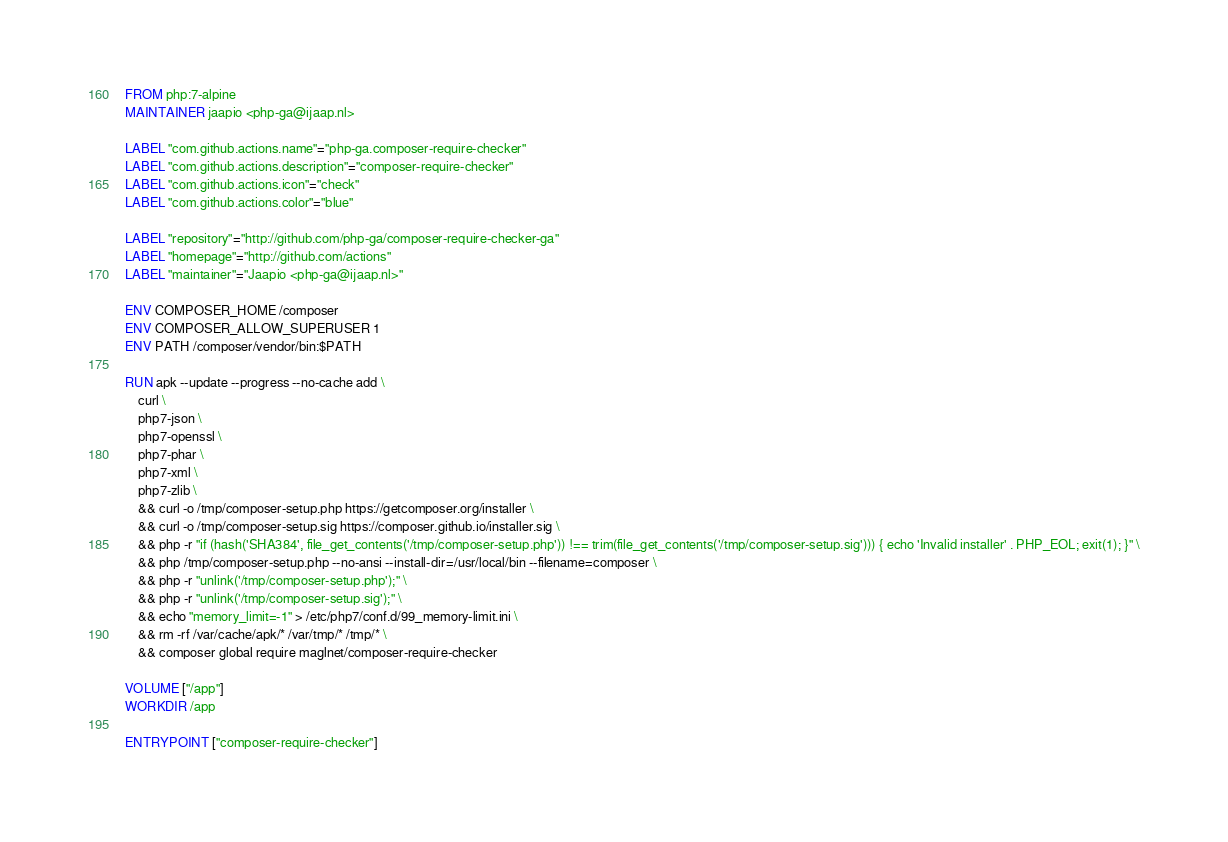<code> <loc_0><loc_0><loc_500><loc_500><_Dockerfile_>FROM php:7-alpine
MAINTAINER jaapio <php-ga@ijaap.nl>

LABEL "com.github.actions.name"="php-ga.composer-require-checker"
LABEL "com.github.actions.description"="composer-require-checker"
LABEL "com.github.actions.icon"="check"
LABEL "com.github.actions.color"="blue"

LABEL "repository"="http://github.com/php-ga/composer-require-checker-ga"
LABEL "homepage"="http://github.com/actions"
LABEL "maintainer"="Jaapio <php-ga@ijaap.nl>"

ENV COMPOSER_HOME /composer
ENV COMPOSER_ALLOW_SUPERUSER 1
ENV PATH /composer/vendor/bin:$PATH

RUN apk --update --progress --no-cache add \
    curl \
    php7-json \
    php7-openssl \
    php7-phar \
    php7-xml \
    php7-zlib \
    && curl -o /tmp/composer-setup.php https://getcomposer.org/installer \
    && curl -o /tmp/composer-setup.sig https://composer.github.io/installer.sig \
    && php -r "if (hash('SHA384', file_get_contents('/tmp/composer-setup.php')) !== trim(file_get_contents('/tmp/composer-setup.sig'))) { echo 'Invalid installer' . PHP_EOL; exit(1); }" \
    && php /tmp/composer-setup.php --no-ansi --install-dir=/usr/local/bin --filename=composer \
    && php -r "unlink('/tmp/composer-setup.php');" \
    && php -r "unlink('/tmp/composer-setup.sig');" \
    && echo "memory_limit=-1" > /etc/php7/conf.d/99_memory-limit.ini \
    && rm -rf /var/cache/apk/* /var/tmp/* /tmp/* \
    && composer global require maglnet/composer-require-checker

VOLUME ["/app"]
WORKDIR /app

ENTRYPOINT ["composer-require-checker"]
</code> 